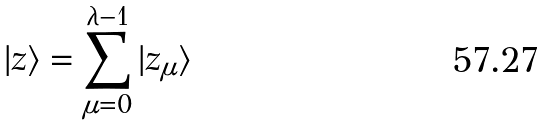Convert formula to latex. <formula><loc_0><loc_0><loc_500><loc_500>| z \rangle = \sum _ { \mu = 0 } ^ { \lambda - 1 } | z _ { \mu } \rangle</formula> 